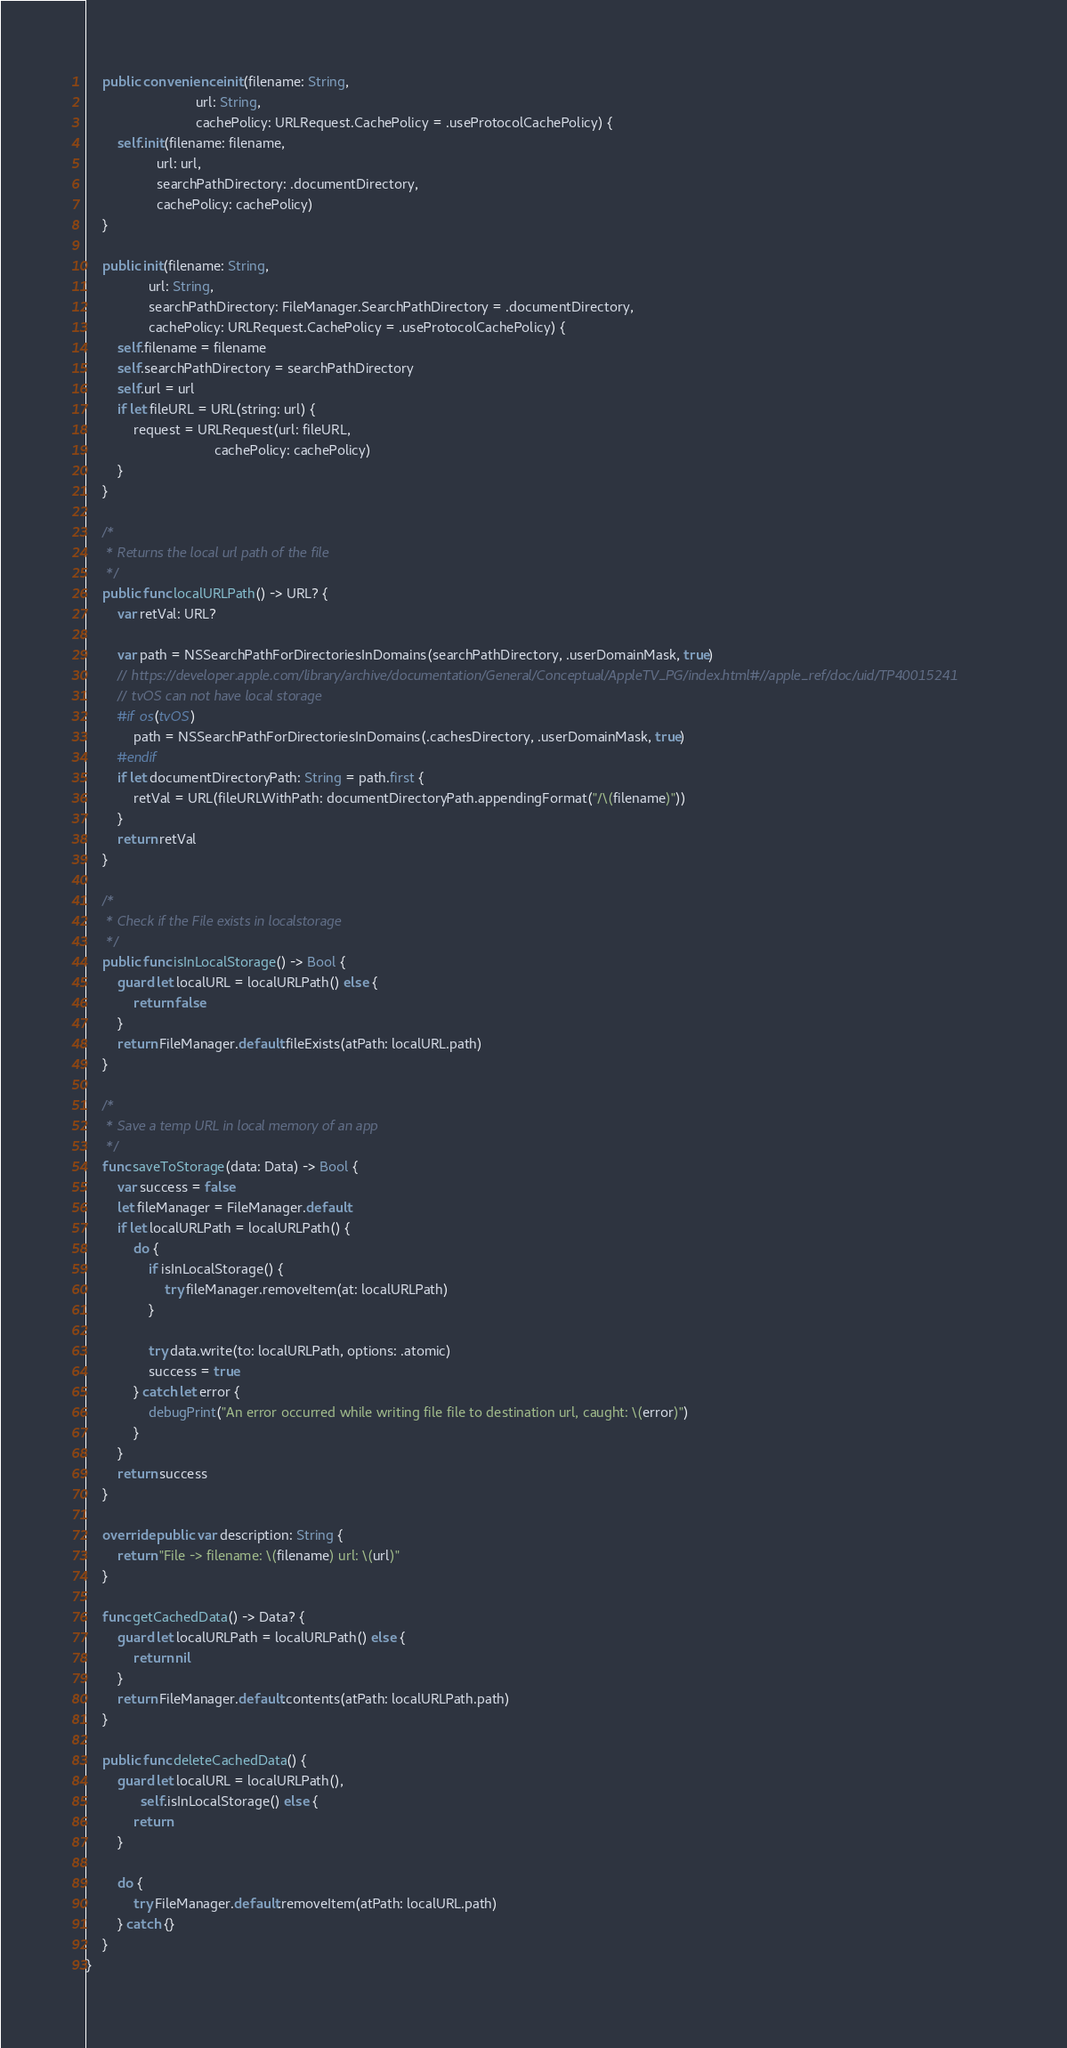<code> <loc_0><loc_0><loc_500><loc_500><_Swift_>    public convenience init(filename: String,
                            url: String,
                            cachePolicy: URLRequest.CachePolicy = .useProtocolCachePolicy) {
        self.init(filename: filename,
                  url: url,
                  searchPathDirectory: .documentDirectory,
                  cachePolicy: cachePolicy)
    }

    public init(filename: String,
                url: String,
                searchPathDirectory: FileManager.SearchPathDirectory = .documentDirectory,
                cachePolicy: URLRequest.CachePolicy = .useProtocolCachePolicy) {
        self.filename = filename
        self.searchPathDirectory = searchPathDirectory
        self.url = url
        if let fileURL = URL(string: url) {
            request = URLRequest(url: fileURL,
                                 cachePolicy: cachePolicy)
        }
    }

    /*
     * Returns the local url path of the file
     */
    public func localURLPath() -> URL? {
        var retVal: URL?

        var path = NSSearchPathForDirectoriesInDomains(searchPathDirectory, .userDomainMask, true)
        // https://developer.apple.com/library/archive/documentation/General/Conceptual/AppleTV_PG/index.html#//apple_ref/doc/uid/TP40015241
        // tvOS can not have local storage
        #if os(tvOS)
            path = NSSearchPathForDirectoriesInDomains(.cachesDirectory, .userDomainMask, true)
        #endif
        if let documentDirectoryPath: String = path.first {
            retVal = URL(fileURLWithPath: documentDirectoryPath.appendingFormat("/\(filename)"))
        }
        return retVal
    }

    /*
     * Check if the File exists in localstorage
     */
    public func isInLocalStorage() -> Bool {
        guard let localURL = localURLPath() else {
            return false
        }
        return FileManager.default.fileExists(atPath: localURL.path)
    }

    /*
     * Save a temp URL in local memory of an app
     */
    func saveToStorage(data: Data) -> Bool {
        var success = false
        let fileManager = FileManager.default
        if let localURLPath = localURLPath() {
            do {
                if isInLocalStorage() {
                    try fileManager.removeItem(at: localURLPath)
                }

                try data.write(to: localURLPath, options: .atomic)
                success = true
            } catch let error {
                debugPrint("An error occurred while writing file file to destination url, caught: \(error)")
            }
        }
        return success
    }

    override public var description: String {
        return "File -> filename: \(filename) url: \(url)"
    }

    func getCachedData() -> Data? {
        guard let localURLPath = localURLPath() else {
            return nil
        }
        return FileManager.default.contents(atPath: localURLPath.path)
    }

    public func deleteCachedData() {
        guard let localURL = localURLPath(),
              self.isInLocalStorage() else {
            return
        }

        do {
            try FileManager.default.removeItem(atPath: localURL.path)
        } catch {}
    }
}
</code> 